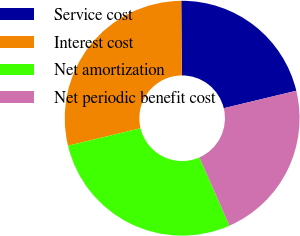Convert chart to OTSL. <chart><loc_0><loc_0><loc_500><loc_500><pie_chart><fcel>Service cost<fcel>Interest cost<fcel>Net amortization<fcel>Net periodic benefit cost<nl><fcel>21.36%<fcel>28.64%<fcel>27.84%<fcel>22.16%<nl></chart> 